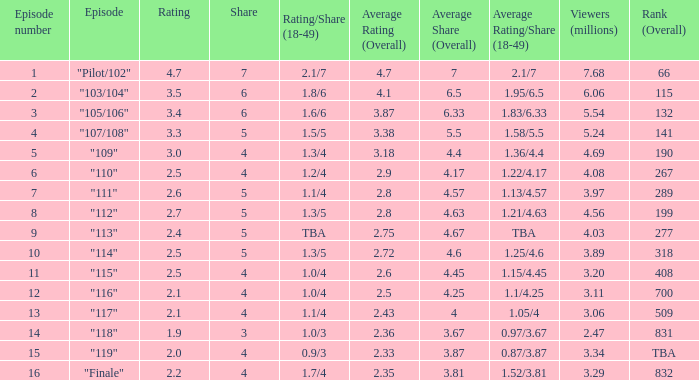WHAT IS THE HIGHEST VIEWERS WITH AN EPISODE LESS THAN 15 AND SHARE LAGER THAN 7? None. 